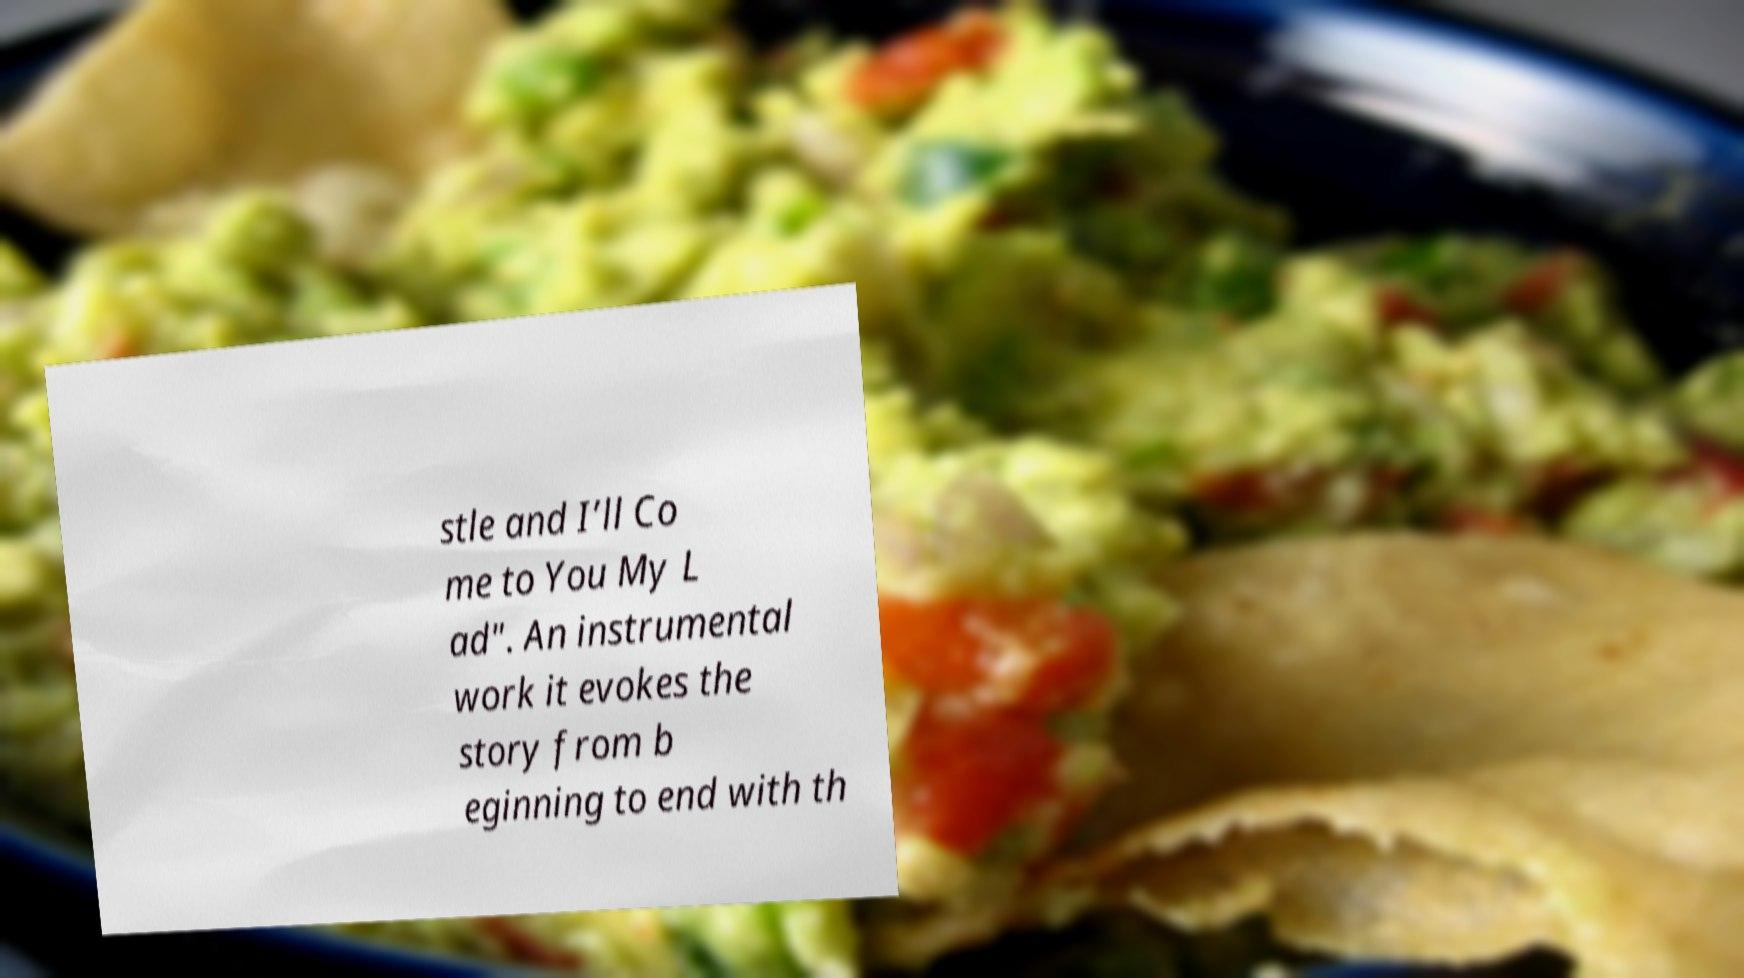What messages or text are displayed in this image? I need them in a readable, typed format. stle and I’ll Co me to You My L ad". An instrumental work it evokes the story from b eginning to end with th 